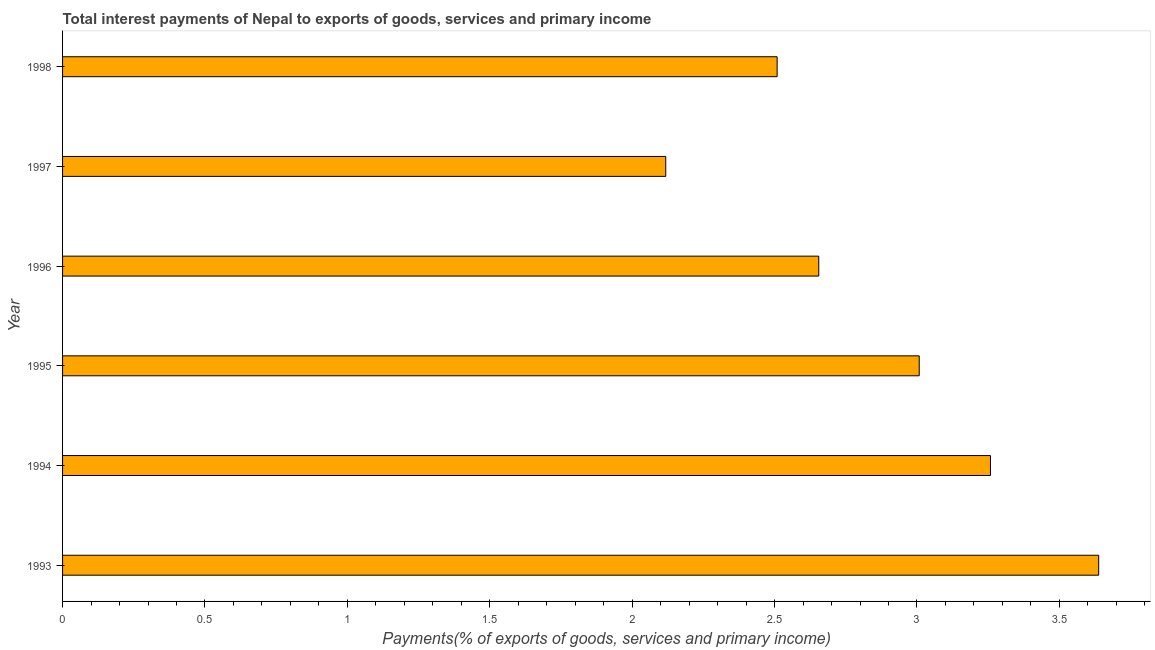Does the graph contain grids?
Your response must be concise. No. What is the title of the graph?
Your answer should be compact. Total interest payments of Nepal to exports of goods, services and primary income. What is the label or title of the X-axis?
Provide a succinct answer. Payments(% of exports of goods, services and primary income). What is the label or title of the Y-axis?
Provide a short and direct response. Year. What is the total interest payments on external debt in 1996?
Offer a very short reply. 2.66. Across all years, what is the maximum total interest payments on external debt?
Your response must be concise. 3.64. Across all years, what is the minimum total interest payments on external debt?
Your response must be concise. 2.12. What is the sum of the total interest payments on external debt?
Offer a very short reply. 17.19. What is the difference between the total interest payments on external debt in 1993 and 1997?
Your answer should be very brief. 1.52. What is the average total interest payments on external debt per year?
Your answer should be compact. 2.86. What is the median total interest payments on external debt?
Keep it short and to the point. 2.83. In how many years, is the total interest payments on external debt greater than 3.2 %?
Your answer should be very brief. 2. Do a majority of the years between 1993 and 1997 (inclusive) have total interest payments on external debt greater than 0.4 %?
Make the answer very short. Yes. What is the ratio of the total interest payments on external debt in 1995 to that in 1998?
Offer a very short reply. 1.2. What is the difference between the highest and the second highest total interest payments on external debt?
Keep it short and to the point. 0.38. Is the sum of the total interest payments on external debt in 1993 and 1996 greater than the maximum total interest payments on external debt across all years?
Your answer should be very brief. Yes. What is the difference between the highest and the lowest total interest payments on external debt?
Offer a very short reply. 1.52. In how many years, is the total interest payments on external debt greater than the average total interest payments on external debt taken over all years?
Provide a short and direct response. 3. How many bars are there?
Give a very brief answer. 6. Are all the bars in the graph horizontal?
Provide a succinct answer. Yes. How many years are there in the graph?
Your answer should be very brief. 6. Are the values on the major ticks of X-axis written in scientific E-notation?
Your response must be concise. No. What is the Payments(% of exports of goods, services and primary income) in 1993?
Keep it short and to the point. 3.64. What is the Payments(% of exports of goods, services and primary income) in 1994?
Offer a terse response. 3.26. What is the Payments(% of exports of goods, services and primary income) of 1995?
Make the answer very short. 3.01. What is the Payments(% of exports of goods, services and primary income) of 1996?
Your response must be concise. 2.66. What is the Payments(% of exports of goods, services and primary income) of 1997?
Make the answer very short. 2.12. What is the Payments(% of exports of goods, services and primary income) in 1998?
Offer a terse response. 2.51. What is the difference between the Payments(% of exports of goods, services and primary income) in 1993 and 1994?
Your response must be concise. 0.38. What is the difference between the Payments(% of exports of goods, services and primary income) in 1993 and 1995?
Your answer should be compact. 0.63. What is the difference between the Payments(% of exports of goods, services and primary income) in 1993 and 1996?
Provide a short and direct response. 0.98. What is the difference between the Payments(% of exports of goods, services and primary income) in 1993 and 1997?
Offer a very short reply. 1.52. What is the difference between the Payments(% of exports of goods, services and primary income) in 1993 and 1998?
Your response must be concise. 1.13. What is the difference between the Payments(% of exports of goods, services and primary income) in 1994 and 1995?
Provide a short and direct response. 0.25. What is the difference between the Payments(% of exports of goods, services and primary income) in 1994 and 1996?
Provide a succinct answer. 0.6. What is the difference between the Payments(% of exports of goods, services and primary income) in 1994 and 1997?
Keep it short and to the point. 1.14. What is the difference between the Payments(% of exports of goods, services and primary income) in 1994 and 1998?
Your answer should be very brief. 0.75. What is the difference between the Payments(% of exports of goods, services and primary income) in 1995 and 1996?
Your answer should be very brief. 0.35. What is the difference between the Payments(% of exports of goods, services and primary income) in 1995 and 1997?
Keep it short and to the point. 0.89. What is the difference between the Payments(% of exports of goods, services and primary income) in 1995 and 1998?
Offer a very short reply. 0.5. What is the difference between the Payments(% of exports of goods, services and primary income) in 1996 and 1997?
Your answer should be compact. 0.54. What is the difference between the Payments(% of exports of goods, services and primary income) in 1996 and 1998?
Your answer should be very brief. 0.15. What is the difference between the Payments(% of exports of goods, services and primary income) in 1997 and 1998?
Provide a short and direct response. -0.39. What is the ratio of the Payments(% of exports of goods, services and primary income) in 1993 to that in 1994?
Provide a short and direct response. 1.12. What is the ratio of the Payments(% of exports of goods, services and primary income) in 1993 to that in 1995?
Give a very brief answer. 1.21. What is the ratio of the Payments(% of exports of goods, services and primary income) in 1993 to that in 1996?
Provide a short and direct response. 1.37. What is the ratio of the Payments(% of exports of goods, services and primary income) in 1993 to that in 1997?
Ensure brevity in your answer.  1.72. What is the ratio of the Payments(% of exports of goods, services and primary income) in 1993 to that in 1998?
Your answer should be compact. 1.45. What is the ratio of the Payments(% of exports of goods, services and primary income) in 1994 to that in 1995?
Offer a terse response. 1.08. What is the ratio of the Payments(% of exports of goods, services and primary income) in 1994 to that in 1996?
Your answer should be compact. 1.23. What is the ratio of the Payments(% of exports of goods, services and primary income) in 1994 to that in 1997?
Keep it short and to the point. 1.54. What is the ratio of the Payments(% of exports of goods, services and primary income) in 1994 to that in 1998?
Make the answer very short. 1.3. What is the ratio of the Payments(% of exports of goods, services and primary income) in 1995 to that in 1996?
Your response must be concise. 1.13. What is the ratio of the Payments(% of exports of goods, services and primary income) in 1995 to that in 1997?
Make the answer very short. 1.42. What is the ratio of the Payments(% of exports of goods, services and primary income) in 1995 to that in 1998?
Offer a very short reply. 1.2. What is the ratio of the Payments(% of exports of goods, services and primary income) in 1996 to that in 1997?
Provide a short and direct response. 1.25. What is the ratio of the Payments(% of exports of goods, services and primary income) in 1996 to that in 1998?
Your answer should be very brief. 1.06. What is the ratio of the Payments(% of exports of goods, services and primary income) in 1997 to that in 1998?
Your answer should be compact. 0.84. 